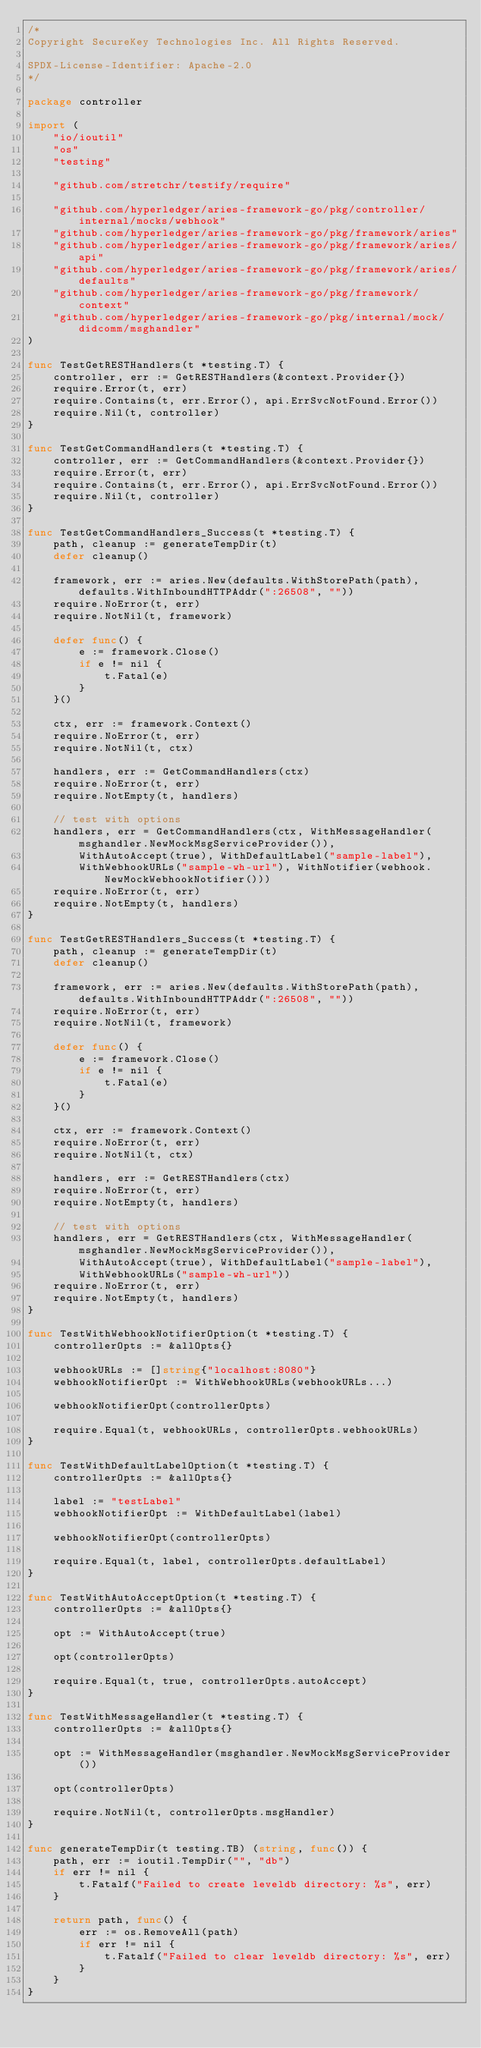<code> <loc_0><loc_0><loc_500><loc_500><_Go_>/*
Copyright SecureKey Technologies Inc. All Rights Reserved.

SPDX-License-Identifier: Apache-2.0
*/

package controller

import (
	"io/ioutil"
	"os"
	"testing"

	"github.com/stretchr/testify/require"

	"github.com/hyperledger/aries-framework-go/pkg/controller/internal/mocks/webhook"
	"github.com/hyperledger/aries-framework-go/pkg/framework/aries"
	"github.com/hyperledger/aries-framework-go/pkg/framework/aries/api"
	"github.com/hyperledger/aries-framework-go/pkg/framework/aries/defaults"
	"github.com/hyperledger/aries-framework-go/pkg/framework/context"
	"github.com/hyperledger/aries-framework-go/pkg/internal/mock/didcomm/msghandler"
)

func TestGetRESTHandlers(t *testing.T) {
	controller, err := GetRESTHandlers(&context.Provider{})
	require.Error(t, err)
	require.Contains(t, err.Error(), api.ErrSvcNotFound.Error())
	require.Nil(t, controller)
}

func TestGetCommandHandlers(t *testing.T) {
	controller, err := GetCommandHandlers(&context.Provider{})
	require.Error(t, err)
	require.Contains(t, err.Error(), api.ErrSvcNotFound.Error())
	require.Nil(t, controller)
}

func TestGetCommandHandlers_Success(t *testing.T) {
	path, cleanup := generateTempDir(t)
	defer cleanup()

	framework, err := aries.New(defaults.WithStorePath(path), defaults.WithInboundHTTPAddr(":26508", ""))
	require.NoError(t, err)
	require.NotNil(t, framework)

	defer func() {
		e := framework.Close()
		if e != nil {
			t.Fatal(e)
		}
	}()

	ctx, err := framework.Context()
	require.NoError(t, err)
	require.NotNil(t, ctx)

	handlers, err := GetCommandHandlers(ctx)
	require.NoError(t, err)
	require.NotEmpty(t, handlers)

	// test with options
	handlers, err = GetCommandHandlers(ctx, WithMessageHandler(msghandler.NewMockMsgServiceProvider()),
		WithAutoAccept(true), WithDefaultLabel("sample-label"),
		WithWebhookURLs("sample-wh-url"), WithNotifier(webhook.NewMockWebhookNotifier()))
	require.NoError(t, err)
	require.NotEmpty(t, handlers)
}

func TestGetRESTHandlers_Success(t *testing.T) {
	path, cleanup := generateTempDir(t)
	defer cleanup()

	framework, err := aries.New(defaults.WithStorePath(path), defaults.WithInboundHTTPAddr(":26508", ""))
	require.NoError(t, err)
	require.NotNil(t, framework)

	defer func() {
		e := framework.Close()
		if e != nil {
			t.Fatal(e)
		}
	}()

	ctx, err := framework.Context()
	require.NoError(t, err)
	require.NotNil(t, ctx)

	handlers, err := GetRESTHandlers(ctx)
	require.NoError(t, err)
	require.NotEmpty(t, handlers)

	// test with options
	handlers, err = GetRESTHandlers(ctx, WithMessageHandler(msghandler.NewMockMsgServiceProvider()),
		WithAutoAccept(true), WithDefaultLabel("sample-label"),
		WithWebhookURLs("sample-wh-url"))
	require.NoError(t, err)
	require.NotEmpty(t, handlers)
}

func TestWithWebhookNotifierOption(t *testing.T) {
	controllerOpts := &allOpts{}

	webhookURLs := []string{"localhost:8080"}
	webhookNotifierOpt := WithWebhookURLs(webhookURLs...)

	webhookNotifierOpt(controllerOpts)

	require.Equal(t, webhookURLs, controllerOpts.webhookURLs)
}

func TestWithDefaultLabelOption(t *testing.T) {
	controllerOpts := &allOpts{}

	label := "testLabel"
	webhookNotifierOpt := WithDefaultLabel(label)

	webhookNotifierOpt(controllerOpts)

	require.Equal(t, label, controllerOpts.defaultLabel)
}

func TestWithAutoAcceptOption(t *testing.T) {
	controllerOpts := &allOpts{}

	opt := WithAutoAccept(true)

	opt(controllerOpts)

	require.Equal(t, true, controllerOpts.autoAccept)
}

func TestWithMessageHandler(t *testing.T) {
	controllerOpts := &allOpts{}

	opt := WithMessageHandler(msghandler.NewMockMsgServiceProvider())

	opt(controllerOpts)

	require.NotNil(t, controllerOpts.msgHandler)
}

func generateTempDir(t testing.TB) (string, func()) {
	path, err := ioutil.TempDir("", "db")
	if err != nil {
		t.Fatalf("Failed to create leveldb directory: %s", err)
	}

	return path, func() {
		err := os.RemoveAll(path)
		if err != nil {
			t.Fatalf("Failed to clear leveldb directory: %s", err)
		}
	}
}
</code> 